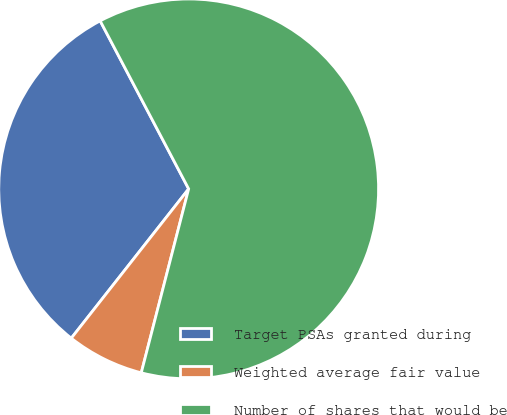<chart> <loc_0><loc_0><loc_500><loc_500><pie_chart><fcel>Target PSAs granted during<fcel>Weighted average fair value<fcel>Number of shares that would be<nl><fcel>31.68%<fcel>6.59%<fcel>61.73%<nl></chart> 